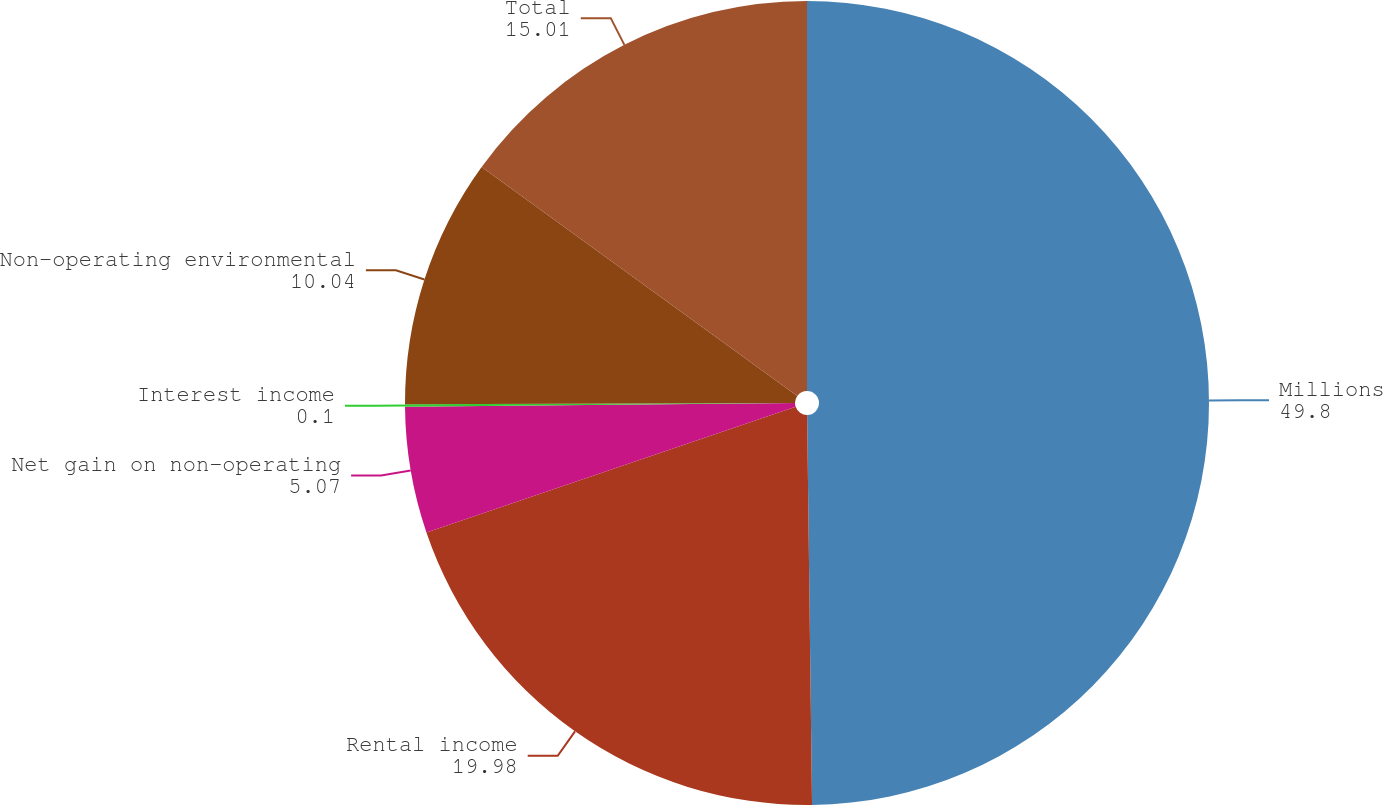<chart> <loc_0><loc_0><loc_500><loc_500><pie_chart><fcel>Millions<fcel>Rental income<fcel>Net gain on non-operating<fcel>Interest income<fcel>Non-operating environmental<fcel>Total<nl><fcel>49.8%<fcel>19.98%<fcel>5.07%<fcel>0.1%<fcel>10.04%<fcel>15.01%<nl></chart> 